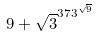<formula> <loc_0><loc_0><loc_500><loc_500>9 + \sqrt { 3 } ^ { 3 7 3 ^ { \sqrt { 9 } } }</formula> 